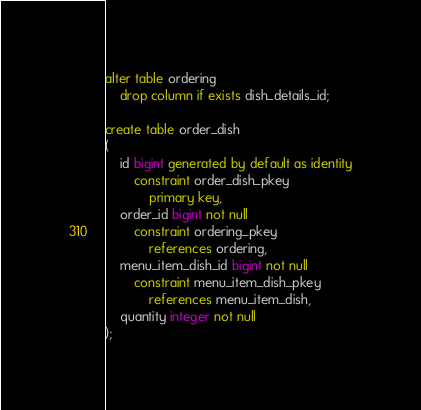<code> <loc_0><loc_0><loc_500><loc_500><_SQL_>alter table ordering
    drop column if exists dish_details_id;

create table order_dish
(
    id bigint generated by default as identity
        constraint order_dish_pkey
            primary key,
    order_id bigint not null
        constraint ordering_pkey
            references ordering,
    menu_item_dish_id bigint not null
        constraint menu_item_dish_pkey
            references menu_item_dish,
    quantity integer not null
);

</code> 